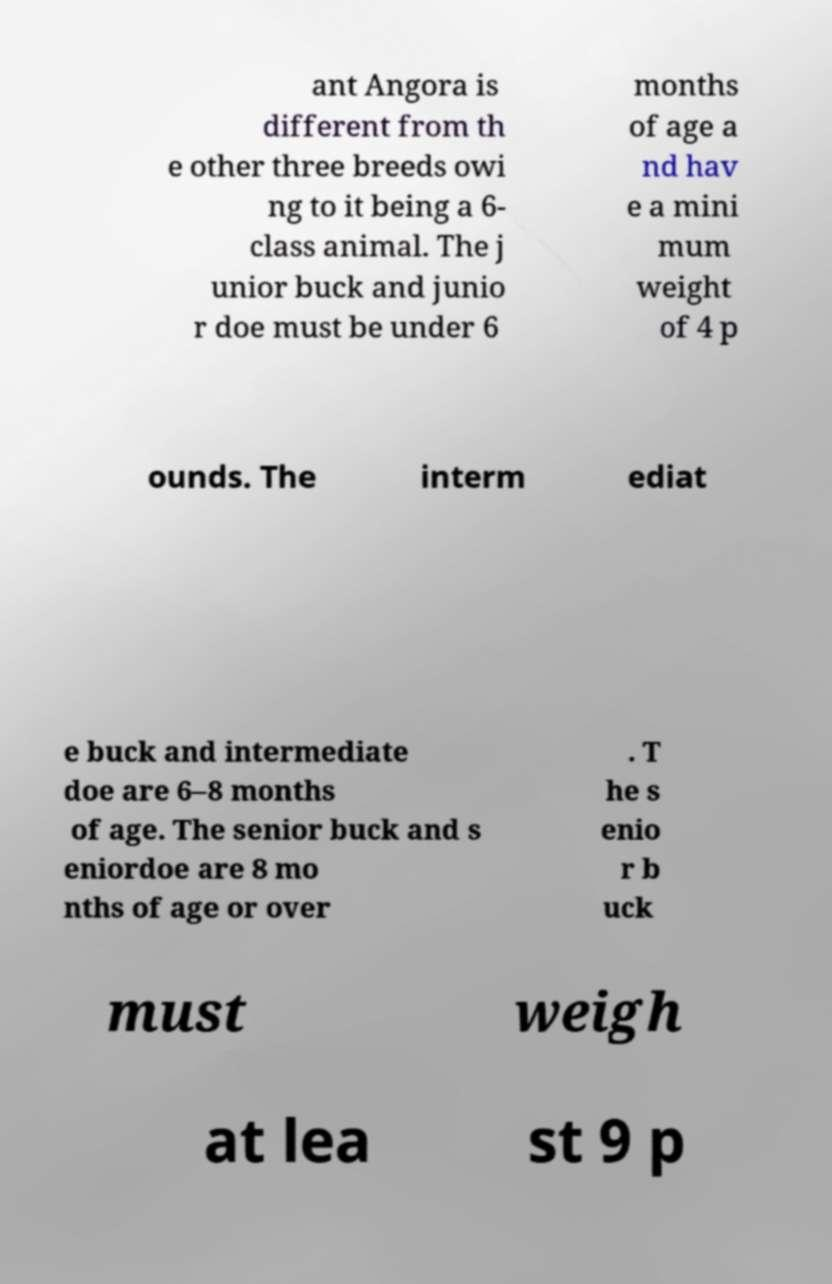Could you assist in decoding the text presented in this image and type it out clearly? ant Angora is different from th e other three breeds owi ng to it being a 6- class animal. The j unior buck and junio r doe must be under 6 months of age a nd hav e a mini mum weight of 4 p ounds. The interm ediat e buck and intermediate doe are 6–8 months of age. The senior buck and s eniordoe are 8 mo nths of age or over . T he s enio r b uck must weigh at lea st 9 p 